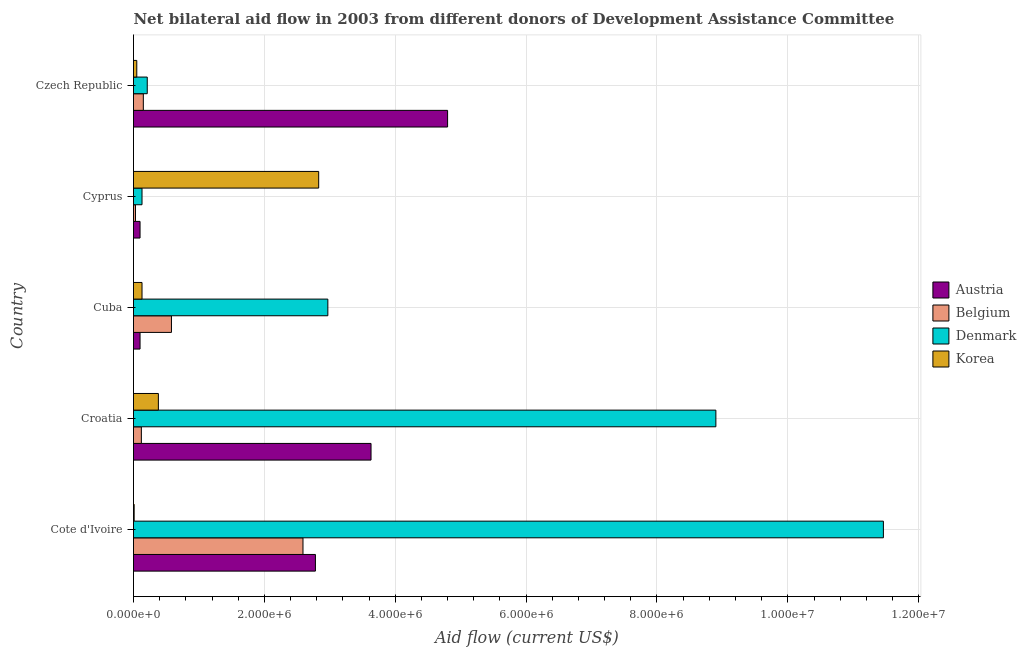How many groups of bars are there?
Your answer should be compact. 5. Are the number of bars per tick equal to the number of legend labels?
Offer a very short reply. Yes. Are the number of bars on each tick of the Y-axis equal?
Provide a short and direct response. Yes. How many bars are there on the 4th tick from the top?
Offer a very short reply. 4. What is the label of the 1st group of bars from the top?
Give a very brief answer. Czech Republic. What is the amount of aid given by austria in Czech Republic?
Make the answer very short. 4.80e+06. Across all countries, what is the maximum amount of aid given by belgium?
Keep it short and to the point. 2.59e+06. Across all countries, what is the minimum amount of aid given by belgium?
Offer a very short reply. 3.00e+04. In which country was the amount of aid given by austria maximum?
Give a very brief answer. Czech Republic. In which country was the amount of aid given by korea minimum?
Ensure brevity in your answer.  Cote d'Ivoire. What is the total amount of aid given by belgium in the graph?
Make the answer very short. 3.47e+06. What is the difference between the amount of aid given by denmark in Croatia and that in Czech Republic?
Your answer should be very brief. 8.69e+06. What is the difference between the amount of aid given by belgium in Croatia and the amount of aid given by denmark in Cyprus?
Ensure brevity in your answer.  -10000. What is the average amount of aid given by korea per country?
Give a very brief answer. 6.80e+05. What is the difference between the amount of aid given by korea and amount of aid given by denmark in Cuba?
Provide a succinct answer. -2.84e+06. In how many countries, is the amount of aid given by denmark greater than 10400000 US$?
Keep it short and to the point. 1. What is the ratio of the amount of aid given by denmark in Croatia to that in Cyprus?
Your response must be concise. 68.46. Is the amount of aid given by belgium in Cote d'Ivoire less than that in Cuba?
Your answer should be compact. No. What is the difference between the highest and the second highest amount of aid given by belgium?
Your answer should be very brief. 2.01e+06. What is the difference between the highest and the lowest amount of aid given by belgium?
Make the answer very short. 2.56e+06. Is it the case that in every country, the sum of the amount of aid given by belgium and amount of aid given by denmark is greater than the sum of amount of aid given by korea and amount of aid given by austria?
Offer a terse response. No. What does the 4th bar from the top in Cote d'Ivoire represents?
Keep it short and to the point. Austria. What does the 1st bar from the bottom in Cote d'Ivoire represents?
Ensure brevity in your answer.  Austria. Are all the bars in the graph horizontal?
Offer a terse response. Yes. Where does the legend appear in the graph?
Provide a short and direct response. Center right. How are the legend labels stacked?
Offer a terse response. Vertical. What is the title of the graph?
Provide a succinct answer. Net bilateral aid flow in 2003 from different donors of Development Assistance Committee. Does "First 20% of population" appear as one of the legend labels in the graph?
Keep it short and to the point. No. What is the label or title of the X-axis?
Your response must be concise. Aid flow (current US$). What is the label or title of the Y-axis?
Ensure brevity in your answer.  Country. What is the Aid flow (current US$) in Austria in Cote d'Ivoire?
Your answer should be compact. 2.78e+06. What is the Aid flow (current US$) in Belgium in Cote d'Ivoire?
Your answer should be compact. 2.59e+06. What is the Aid flow (current US$) in Denmark in Cote d'Ivoire?
Your answer should be very brief. 1.15e+07. What is the Aid flow (current US$) of Korea in Cote d'Ivoire?
Your answer should be very brief. 10000. What is the Aid flow (current US$) in Austria in Croatia?
Provide a short and direct response. 3.63e+06. What is the Aid flow (current US$) of Denmark in Croatia?
Provide a short and direct response. 8.90e+06. What is the Aid flow (current US$) in Belgium in Cuba?
Make the answer very short. 5.80e+05. What is the Aid flow (current US$) of Denmark in Cuba?
Provide a short and direct response. 2.97e+06. What is the Aid flow (current US$) in Belgium in Cyprus?
Offer a very short reply. 3.00e+04. What is the Aid flow (current US$) of Denmark in Cyprus?
Provide a succinct answer. 1.30e+05. What is the Aid flow (current US$) of Korea in Cyprus?
Offer a terse response. 2.83e+06. What is the Aid flow (current US$) in Austria in Czech Republic?
Provide a short and direct response. 4.80e+06. What is the Aid flow (current US$) of Korea in Czech Republic?
Your answer should be very brief. 5.00e+04. Across all countries, what is the maximum Aid flow (current US$) of Austria?
Your answer should be very brief. 4.80e+06. Across all countries, what is the maximum Aid flow (current US$) of Belgium?
Offer a very short reply. 2.59e+06. Across all countries, what is the maximum Aid flow (current US$) in Denmark?
Keep it short and to the point. 1.15e+07. Across all countries, what is the maximum Aid flow (current US$) of Korea?
Your response must be concise. 2.83e+06. What is the total Aid flow (current US$) in Austria in the graph?
Keep it short and to the point. 1.14e+07. What is the total Aid flow (current US$) of Belgium in the graph?
Offer a very short reply. 3.47e+06. What is the total Aid flow (current US$) in Denmark in the graph?
Your answer should be compact. 2.37e+07. What is the total Aid flow (current US$) of Korea in the graph?
Ensure brevity in your answer.  3.40e+06. What is the difference between the Aid flow (current US$) of Austria in Cote d'Ivoire and that in Croatia?
Keep it short and to the point. -8.50e+05. What is the difference between the Aid flow (current US$) in Belgium in Cote d'Ivoire and that in Croatia?
Your answer should be compact. 2.47e+06. What is the difference between the Aid flow (current US$) of Denmark in Cote d'Ivoire and that in Croatia?
Your response must be concise. 2.56e+06. What is the difference between the Aid flow (current US$) in Korea in Cote d'Ivoire and that in Croatia?
Ensure brevity in your answer.  -3.70e+05. What is the difference between the Aid flow (current US$) of Austria in Cote d'Ivoire and that in Cuba?
Provide a succinct answer. 2.68e+06. What is the difference between the Aid flow (current US$) of Belgium in Cote d'Ivoire and that in Cuba?
Offer a very short reply. 2.01e+06. What is the difference between the Aid flow (current US$) of Denmark in Cote d'Ivoire and that in Cuba?
Ensure brevity in your answer.  8.49e+06. What is the difference between the Aid flow (current US$) of Korea in Cote d'Ivoire and that in Cuba?
Make the answer very short. -1.20e+05. What is the difference between the Aid flow (current US$) of Austria in Cote d'Ivoire and that in Cyprus?
Keep it short and to the point. 2.68e+06. What is the difference between the Aid flow (current US$) in Belgium in Cote d'Ivoire and that in Cyprus?
Provide a succinct answer. 2.56e+06. What is the difference between the Aid flow (current US$) of Denmark in Cote d'Ivoire and that in Cyprus?
Provide a short and direct response. 1.13e+07. What is the difference between the Aid flow (current US$) in Korea in Cote d'Ivoire and that in Cyprus?
Give a very brief answer. -2.82e+06. What is the difference between the Aid flow (current US$) of Austria in Cote d'Ivoire and that in Czech Republic?
Keep it short and to the point. -2.02e+06. What is the difference between the Aid flow (current US$) of Belgium in Cote d'Ivoire and that in Czech Republic?
Your answer should be compact. 2.44e+06. What is the difference between the Aid flow (current US$) in Denmark in Cote d'Ivoire and that in Czech Republic?
Your response must be concise. 1.12e+07. What is the difference between the Aid flow (current US$) in Korea in Cote d'Ivoire and that in Czech Republic?
Provide a short and direct response. -4.00e+04. What is the difference between the Aid flow (current US$) in Austria in Croatia and that in Cuba?
Your answer should be very brief. 3.53e+06. What is the difference between the Aid flow (current US$) in Belgium in Croatia and that in Cuba?
Provide a short and direct response. -4.60e+05. What is the difference between the Aid flow (current US$) in Denmark in Croatia and that in Cuba?
Your response must be concise. 5.93e+06. What is the difference between the Aid flow (current US$) in Korea in Croatia and that in Cuba?
Your answer should be compact. 2.50e+05. What is the difference between the Aid flow (current US$) in Austria in Croatia and that in Cyprus?
Offer a terse response. 3.53e+06. What is the difference between the Aid flow (current US$) in Belgium in Croatia and that in Cyprus?
Give a very brief answer. 9.00e+04. What is the difference between the Aid flow (current US$) of Denmark in Croatia and that in Cyprus?
Your answer should be very brief. 8.77e+06. What is the difference between the Aid flow (current US$) of Korea in Croatia and that in Cyprus?
Your response must be concise. -2.45e+06. What is the difference between the Aid flow (current US$) of Austria in Croatia and that in Czech Republic?
Provide a succinct answer. -1.17e+06. What is the difference between the Aid flow (current US$) of Denmark in Croatia and that in Czech Republic?
Offer a terse response. 8.69e+06. What is the difference between the Aid flow (current US$) in Korea in Croatia and that in Czech Republic?
Ensure brevity in your answer.  3.30e+05. What is the difference between the Aid flow (current US$) of Austria in Cuba and that in Cyprus?
Your answer should be compact. 0. What is the difference between the Aid flow (current US$) in Denmark in Cuba and that in Cyprus?
Your answer should be very brief. 2.84e+06. What is the difference between the Aid flow (current US$) in Korea in Cuba and that in Cyprus?
Ensure brevity in your answer.  -2.70e+06. What is the difference between the Aid flow (current US$) in Austria in Cuba and that in Czech Republic?
Provide a short and direct response. -4.70e+06. What is the difference between the Aid flow (current US$) of Belgium in Cuba and that in Czech Republic?
Make the answer very short. 4.30e+05. What is the difference between the Aid flow (current US$) in Denmark in Cuba and that in Czech Republic?
Your response must be concise. 2.76e+06. What is the difference between the Aid flow (current US$) in Austria in Cyprus and that in Czech Republic?
Make the answer very short. -4.70e+06. What is the difference between the Aid flow (current US$) in Belgium in Cyprus and that in Czech Republic?
Your answer should be very brief. -1.20e+05. What is the difference between the Aid flow (current US$) of Denmark in Cyprus and that in Czech Republic?
Make the answer very short. -8.00e+04. What is the difference between the Aid flow (current US$) of Korea in Cyprus and that in Czech Republic?
Your answer should be very brief. 2.78e+06. What is the difference between the Aid flow (current US$) of Austria in Cote d'Ivoire and the Aid flow (current US$) of Belgium in Croatia?
Provide a succinct answer. 2.66e+06. What is the difference between the Aid flow (current US$) of Austria in Cote d'Ivoire and the Aid flow (current US$) of Denmark in Croatia?
Provide a succinct answer. -6.12e+06. What is the difference between the Aid flow (current US$) in Austria in Cote d'Ivoire and the Aid flow (current US$) in Korea in Croatia?
Give a very brief answer. 2.40e+06. What is the difference between the Aid flow (current US$) of Belgium in Cote d'Ivoire and the Aid flow (current US$) of Denmark in Croatia?
Make the answer very short. -6.31e+06. What is the difference between the Aid flow (current US$) of Belgium in Cote d'Ivoire and the Aid flow (current US$) of Korea in Croatia?
Provide a succinct answer. 2.21e+06. What is the difference between the Aid flow (current US$) in Denmark in Cote d'Ivoire and the Aid flow (current US$) in Korea in Croatia?
Your response must be concise. 1.11e+07. What is the difference between the Aid flow (current US$) of Austria in Cote d'Ivoire and the Aid flow (current US$) of Belgium in Cuba?
Offer a terse response. 2.20e+06. What is the difference between the Aid flow (current US$) of Austria in Cote d'Ivoire and the Aid flow (current US$) of Korea in Cuba?
Your answer should be very brief. 2.65e+06. What is the difference between the Aid flow (current US$) of Belgium in Cote d'Ivoire and the Aid flow (current US$) of Denmark in Cuba?
Your answer should be compact. -3.80e+05. What is the difference between the Aid flow (current US$) of Belgium in Cote d'Ivoire and the Aid flow (current US$) of Korea in Cuba?
Keep it short and to the point. 2.46e+06. What is the difference between the Aid flow (current US$) in Denmark in Cote d'Ivoire and the Aid flow (current US$) in Korea in Cuba?
Your answer should be very brief. 1.13e+07. What is the difference between the Aid flow (current US$) of Austria in Cote d'Ivoire and the Aid flow (current US$) of Belgium in Cyprus?
Your answer should be very brief. 2.75e+06. What is the difference between the Aid flow (current US$) in Austria in Cote d'Ivoire and the Aid flow (current US$) in Denmark in Cyprus?
Provide a succinct answer. 2.65e+06. What is the difference between the Aid flow (current US$) of Belgium in Cote d'Ivoire and the Aid flow (current US$) of Denmark in Cyprus?
Your answer should be very brief. 2.46e+06. What is the difference between the Aid flow (current US$) of Belgium in Cote d'Ivoire and the Aid flow (current US$) of Korea in Cyprus?
Offer a very short reply. -2.40e+05. What is the difference between the Aid flow (current US$) in Denmark in Cote d'Ivoire and the Aid flow (current US$) in Korea in Cyprus?
Keep it short and to the point. 8.63e+06. What is the difference between the Aid flow (current US$) in Austria in Cote d'Ivoire and the Aid flow (current US$) in Belgium in Czech Republic?
Your answer should be compact. 2.63e+06. What is the difference between the Aid flow (current US$) in Austria in Cote d'Ivoire and the Aid flow (current US$) in Denmark in Czech Republic?
Your answer should be very brief. 2.57e+06. What is the difference between the Aid flow (current US$) in Austria in Cote d'Ivoire and the Aid flow (current US$) in Korea in Czech Republic?
Provide a succinct answer. 2.73e+06. What is the difference between the Aid flow (current US$) of Belgium in Cote d'Ivoire and the Aid flow (current US$) of Denmark in Czech Republic?
Offer a very short reply. 2.38e+06. What is the difference between the Aid flow (current US$) in Belgium in Cote d'Ivoire and the Aid flow (current US$) in Korea in Czech Republic?
Provide a succinct answer. 2.54e+06. What is the difference between the Aid flow (current US$) in Denmark in Cote d'Ivoire and the Aid flow (current US$) in Korea in Czech Republic?
Your response must be concise. 1.14e+07. What is the difference between the Aid flow (current US$) of Austria in Croatia and the Aid flow (current US$) of Belgium in Cuba?
Provide a succinct answer. 3.05e+06. What is the difference between the Aid flow (current US$) in Austria in Croatia and the Aid flow (current US$) in Denmark in Cuba?
Keep it short and to the point. 6.60e+05. What is the difference between the Aid flow (current US$) of Austria in Croatia and the Aid flow (current US$) of Korea in Cuba?
Provide a succinct answer. 3.50e+06. What is the difference between the Aid flow (current US$) of Belgium in Croatia and the Aid flow (current US$) of Denmark in Cuba?
Make the answer very short. -2.85e+06. What is the difference between the Aid flow (current US$) in Denmark in Croatia and the Aid flow (current US$) in Korea in Cuba?
Keep it short and to the point. 8.77e+06. What is the difference between the Aid flow (current US$) in Austria in Croatia and the Aid flow (current US$) in Belgium in Cyprus?
Provide a succinct answer. 3.60e+06. What is the difference between the Aid flow (current US$) in Austria in Croatia and the Aid flow (current US$) in Denmark in Cyprus?
Give a very brief answer. 3.50e+06. What is the difference between the Aid flow (current US$) of Belgium in Croatia and the Aid flow (current US$) of Denmark in Cyprus?
Offer a terse response. -10000. What is the difference between the Aid flow (current US$) in Belgium in Croatia and the Aid flow (current US$) in Korea in Cyprus?
Give a very brief answer. -2.71e+06. What is the difference between the Aid flow (current US$) in Denmark in Croatia and the Aid flow (current US$) in Korea in Cyprus?
Provide a succinct answer. 6.07e+06. What is the difference between the Aid flow (current US$) of Austria in Croatia and the Aid flow (current US$) of Belgium in Czech Republic?
Keep it short and to the point. 3.48e+06. What is the difference between the Aid flow (current US$) in Austria in Croatia and the Aid flow (current US$) in Denmark in Czech Republic?
Make the answer very short. 3.42e+06. What is the difference between the Aid flow (current US$) in Austria in Croatia and the Aid flow (current US$) in Korea in Czech Republic?
Give a very brief answer. 3.58e+06. What is the difference between the Aid flow (current US$) of Belgium in Croatia and the Aid flow (current US$) of Korea in Czech Republic?
Your response must be concise. 7.00e+04. What is the difference between the Aid flow (current US$) of Denmark in Croatia and the Aid flow (current US$) of Korea in Czech Republic?
Give a very brief answer. 8.85e+06. What is the difference between the Aid flow (current US$) in Austria in Cuba and the Aid flow (current US$) in Korea in Cyprus?
Your answer should be very brief. -2.73e+06. What is the difference between the Aid flow (current US$) in Belgium in Cuba and the Aid flow (current US$) in Denmark in Cyprus?
Give a very brief answer. 4.50e+05. What is the difference between the Aid flow (current US$) in Belgium in Cuba and the Aid flow (current US$) in Korea in Cyprus?
Provide a short and direct response. -2.25e+06. What is the difference between the Aid flow (current US$) of Austria in Cuba and the Aid flow (current US$) of Belgium in Czech Republic?
Your answer should be compact. -5.00e+04. What is the difference between the Aid flow (current US$) in Belgium in Cuba and the Aid flow (current US$) in Korea in Czech Republic?
Offer a very short reply. 5.30e+05. What is the difference between the Aid flow (current US$) of Denmark in Cuba and the Aid flow (current US$) of Korea in Czech Republic?
Your response must be concise. 2.92e+06. What is the difference between the Aid flow (current US$) of Austria in Cyprus and the Aid flow (current US$) of Belgium in Czech Republic?
Keep it short and to the point. -5.00e+04. What is the difference between the Aid flow (current US$) in Austria in Cyprus and the Aid flow (current US$) in Denmark in Czech Republic?
Offer a terse response. -1.10e+05. What is the difference between the Aid flow (current US$) of Austria in Cyprus and the Aid flow (current US$) of Korea in Czech Republic?
Your answer should be compact. 5.00e+04. What is the difference between the Aid flow (current US$) in Denmark in Cyprus and the Aid flow (current US$) in Korea in Czech Republic?
Provide a succinct answer. 8.00e+04. What is the average Aid flow (current US$) of Austria per country?
Your answer should be very brief. 2.28e+06. What is the average Aid flow (current US$) in Belgium per country?
Offer a terse response. 6.94e+05. What is the average Aid flow (current US$) of Denmark per country?
Offer a very short reply. 4.73e+06. What is the average Aid flow (current US$) of Korea per country?
Your answer should be very brief. 6.80e+05. What is the difference between the Aid flow (current US$) of Austria and Aid flow (current US$) of Denmark in Cote d'Ivoire?
Provide a succinct answer. -8.68e+06. What is the difference between the Aid flow (current US$) of Austria and Aid flow (current US$) of Korea in Cote d'Ivoire?
Provide a short and direct response. 2.77e+06. What is the difference between the Aid flow (current US$) in Belgium and Aid flow (current US$) in Denmark in Cote d'Ivoire?
Give a very brief answer. -8.87e+06. What is the difference between the Aid flow (current US$) in Belgium and Aid flow (current US$) in Korea in Cote d'Ivoire?
Make the answer very short. 2.58e+06. What is the difference between the Aid flow (current US$) in Denmark and Aid flow (current US$) in Korea in Cote d'Ivoire?
Keep it short and to the point. 1.14e+07. What is the difference between the Aid flow (current US$) of Austria and Aid flow (current US$) of Belgium in Croatia?
Your answer should be compact. 3.51e+06. What is the difference between the Aid flow (current US$) of Austria and Aid flow (current US$) of Denmark in Croatia?
Your response must be concise. -5.27e+06. What is the difference between the Aid flow (current US$) of Austria and Aid flow (current US$) of Korea in Croatia?
Your answer should be compact. 3.25e+06. What is the difference between the Aid flow (current US$) of Belgium and Aid flow (current US$) of Denmark in Croatia?
Your response must be concise. -8.78e+06. What is the difference between the Aid flow (current US$) in Denmark and Aid flow (current US$) in Korea in Croatia?
Your answer should be very brief. 8.52e+06. What is the difference between the Aid flow (current US$) in Austria and Aid flow (current US$) in Belgium in Cuba?
Ensure brevity in your answer.  -4.80e+05. What is the difference between the Aid flow (current US$) of Austria and Aid flow (current US$) of Denmark in Cuba?
Your answer should be very brief. -2.87e+06. What is the difference between the Aid flow (current US$) of Belgium and Aid flow (current US$) of Denmark in Cuba?
Offer a terse response. -2.39e+06. What is the difference between the Aid flow (current US$) of Denmark and Aid flow (current US$) of Korea in Cuba?
Your answer should be compact. 2.84e+06. What is the difference between the Aid flow (current US$) in Austria and Aid flow (current US$) in Belgium in Cyprus?
Provide a succinct answer. 7.00e+04. What is the difference between the Aid flow (current US$) in Austria and Aid flow (current US$) in Korea in Cyprus?
Your answer should be very brief. -2.73e+06. What is the difference between the Aid flow (current US$) in Belgium and Aid flow (current US$) in Korea in Cyprus?
Your answer should be very brief. -2.80e+06. What is the difference between the Aid flow (current US$) of Denmark and Aid flow (current US$) of Korea in Cyprus?
Provide a short and direct response. -2.70e+06. What is the difference between the Aid flow (current US$) in Austria and Aid flow (current US$) in Belgium in Czech Republic?
Provide a short and direct response. 4.65e+06. What is the difference between the Aid flow (current US$) of Austria and Aid flow (current US$) of Denmark in Czech Republic?
Give a very brief answer. 4.59e+06. What is the difference between the Aid flow (current US$) in Austria and Aid flow (current US$) in Korea in Czech Republic?
Provide a succinct answer. 4.75e+06. What is the difference between the Aid flow (current US$) in Belgium and Aid flow (current US$) in Korea in Czech Republic?
Offer a terse response. 1.00e+05. What is the ratio of the Aid flow (current US$) in Austria in Cote d'Ivoire to that in Croatia?
Offer a terse response. 0.77. What is the ratio of the Aid flow (current US$) in Belgium in Cote d'Ivoire to that in Croatia?
Make the answer very short. 21.58. What is the ratio of the Aid flow (current US$) in Denmark in Cote d'Ivoire to that in Croatia?
Give a very brief answer. 1.29. What is the ratio of the Aid flow (current US$) in Korea in Cote d'Ivoire to that in Croatia?
Your answer should be compact. 0.03. What is the ratio of the Aid flow (current US$) in Austria in Cote d'Ivoire to that in Cuba?
Give a very brief answer. 27.8. What is the ratio of the Aid flow (current US$) of Belgium in Cote d'Ivoire to that in Cuba?
Provide a short and direct response. 4.47. What is the ratio of the Aid flow (current US$) of Denmark in Cote d'Ivoire to that in Cuba?
Provide a succinct answer. 3.86. What is the ratio of the Aid flow (current US$) of Korea in Cote d'Ivoire to that in Cuba?
Your answer should be very brief. 0.08. What is the ratio of the Aid flow (current US$) of Austria in Cote d'Ivoire to that in Cyprus?
Your answer should be compact. 27.8. What is the ratio of the Aid flow (current US$) of Belgium in Cote d'Ivoire to that in Cyprus?
Provide a succinct answer. 86.33. What is the ratio of the Aid flow (current US$) in Denmark in Cote d'Ivoire to that in Cyprus?
Provide a short and direct response. 88.15. What is the ratio of the Aid flow (current US$) in Korea in Cote d'Ivoire to that in Cyprus?
Keep it short and to the point. 0. What is the ratio of the Aid flow (current US$) of Austria in Cote d'Ivoire to that in Czech Republic?
Keep it short and to the point. 0.58. What is the ratio of the Aid flow (current US$) of Belgium in Cote d'Ivoire to that in Czech Republic?
Your response must be concise. 17.27. What is the ratio of the Aid flow (current US$) of Denmark in Cote d'Ivoire to that in Czech Republic?
Your answer should be compact. 54.57. What is the ratio of the Aid flow (current US$) in Austria in Croatia to that in Cuba?
Your answer should be compact. 36.3. What is the ratio of the Aid flow (current US$) of Belgium in Croatia to that in Cuba?
Your answer should be very brief. 0.21. What is the ratio of the Aid flow (current US$) of Denmark in Croatia to that in Cuba?
Provide a short and direct response. 3. What is the ratio of the Aid flow (current US$) in Korea in Croatia to that in Cuba?
Offer a very short reply. 2.92. What is the ratio of the Aid flow (current US$) of Austria in Croatia to that in Cyprus?
Offer a very short reply. 36.3. What is the ratio of the Aid flow (current US$) of Denmark in Croatia to that in Cyprus?
Provide a short and direct response. 68.46. What is the ratio of the Aid flow (current US$) in Korea in Croatia to that in Cyprus?
Give a very brief answer. 0.13. What is the ratio of the Aid flow (current US$) in Austria in Croatia to that in Czech Republic?
Provide a succinct answer. 0.76. What is the ratio of the Aid flow (current US$) of Denmark in Croatia to that in Czech Republic?
Provide a short and direct response. 42.38. What is the ratio of the Aid flow (current US$) of Belgium in Cuba to that in Cyprus?
Make the answer very short. 19.33. What is the ratio of the Aid flow (current US$) in Denmark in Cuba to that in Cyprus?
Your response must be concise. 22.85. What is the ratio of the Aid flow (current US$) of Korea in Cuba to that in Cyprus?
Make the answer very short. 0.05. What is the ratio of the Aid flow (current US$) of Austria in Cuba to that in Czech Republic?
Give a very brief answer. 0.02. What is the ratio of the Aid flow (current US$) of Belgium in Cuba to that in Czech Republic?
Ensure brevity in your answer.  3.87. What is the ratio of the Aid flow (current US$) in Denmark in Cuba to that in Czech Republic?
Your response must be concise. 14.14. What is the ratio of the Aid flow (current US$) of Austria in Cyprus to that in Czech Republic?
Your response must be concise. 0.02. What is the ratio of the Aid flow (current US$) of Denmark in Cyprus to that in Czech Republic?
Provide a short and direct response. 0.62. What is the ratio of the Aid flow (current US$) in Korea in Cyprus to that in Czech Republic?
Your response must be concise. 56.6. What is the difference between the highest and the second highest Aid flow (current US$) in Austria?
Make the answer very short. 1.17e+06. What is the difference between the highest and the second highest Aid flow (current US$) of Belgium?
Your answer should be compact. 2.01e+06. What is the difference between the highest and the second highest Aid flow (current US$) in Denmark?
Offer a very short reply. 2.56e+06. What is the difference between the highest and the second highest Aid flow (current US$) of Korea?
Your answer should be very brief. 2.45e+06. What is the difference between the highest and the lowest Aid flow (current US$) in Austria?
Provide a short and direct response. 4.70e+06. What is the difference between the highest and the lowest Aid flow (current US$) in Belgium?
Ensure brevity in your answer.  2.56e+06. What is the difference between the highest and the lowest Aid flow (current US$) of Denmark?
Your answer should be very brief. 1.13e+07. What is the difference between the highest and the lowest Aid flow (current US$) in Korea?
Offer a very short reply. 2.82e+06. 